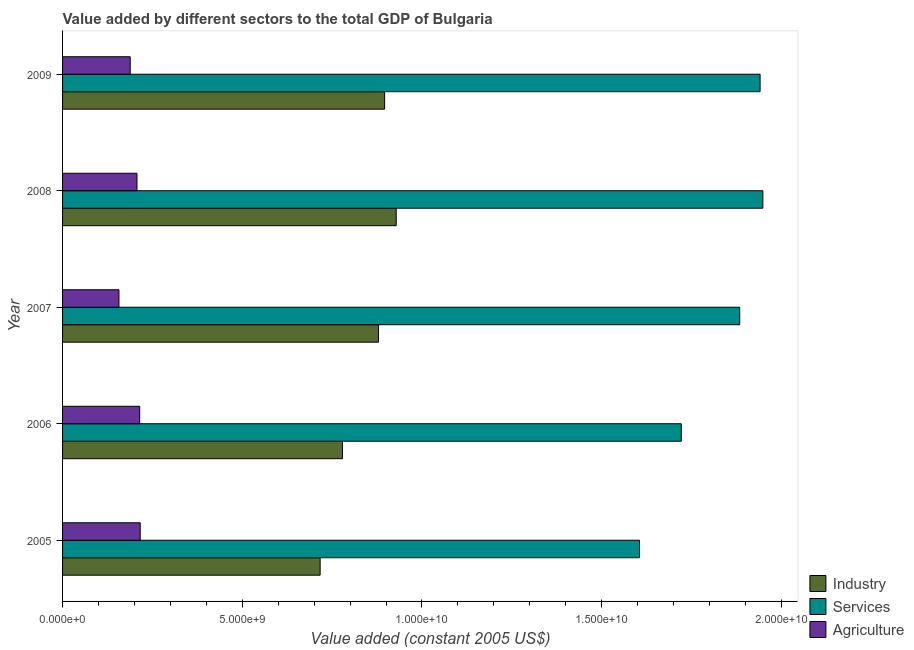How many different coloured bars are there?
Provide a short and direct response. 3. How many groups of bars are there?
Your response must be concise. 5. Are the number of bars on each tick of the Y-axis equal?
Provide a short and direct response. Yes. How many bars are there on the 1st tick from the top?
Ensure brevity in your answer.  3. How many bars are there on the 4th tick from the bottom?
Your answer should be very brief. 3. What is the label of the 4th group of bars from the top?
Ensure brevity in your answer.  2006. What is the value added by services in 2005?
Give a very brief answer. 1.61e+1. Across all years, what is the maximum value added by agricultural sector?
Your answer should be compact. 2.16e+09. Across all years, what is the minimum value added by industrial sector?
Keep it short and to the point. 7.17e+09. What is the total value added by industrial sector in the graph?
Your answer should be very brief. 4.20e+1. What is the difference between the value added by agricultural sector in 2007 and that in 2008?
Offer a terse response. -5.01e+08. What is the difference between the value added by agricultural sector in 2007 and the value added by services in 2009?
Offer a very short reply. -1.78e+1. What is the average value added by agricultural sector per year?
Your answer should be very brief. 1.97e+09. In the year 2009, what is the difference between the value added by services and value added by industrial sector?
Keep it short and to the point. 1.04e+1. What is the ratio of the value added by agricultural sector in 2005 to that in 2009?
Offer a very short reply. 1.15. What is the difference between the highest and the second highest value added by services?
Provide a short and direct response. 7.76e+07. What is the difference between the highest and the lowest value added by agricultural sector?
Your answer should be compact. 5.91e+08. What does the 2nd bar from the top in 2005 represents?
Your answer should be compact. Services. What does the 2nd bar from the bottom in 2008 represents?
Your answer should be compact. Services. Are all the bars in the graph horizontal?
Ensure brevity in your answer.  Yes. What is the difference between two consecutive major ticks on the X-axis?
Give a very brief answer. 5.00e+09. Are the values on the major ticks of X-axis written in scientific E-notation?
Make the answer very short. Yes. Does the graph contain any zero values?
Your answer should be very brief. No. Where does the legend appear in the graph?
Offer a terse response. Bottom right. How many legend labels are there?
Your answer should be compact. 3. What is the title of the graph?
Offer a very short reply. Value added by different sectors to the total GDP of Bulgaria. What is the label or title of the X-axis?
Make the answer very short. Value added (constant 2005 US$). What is the Value added (constant 2005 US$) in Industry in 2005?
Your response must be concise. 7.17e+09. What is the Value added (constant 2005 US$) in Services in 2005?
Make the answer very short. 1.61e+1. What is the Value added (constant 2005 US$) in Agriculture in 2005?
Keep it short and to the point. 2.16e+09. What is the Value added (constant 2005 US$) of Industry in 2006?
Provide a short and direct response. 7.79e+09. What is the Value added (constant 2005 US$) of Services in 2006?
Your response must be concise. 1.72e+1. What is the Value added (constant 2005 US$) of Agriculture in 2006?
Offer a very short reply. 2.15e+09. What is the Value added (constant 2005 US$) in Industry in 2007?
Your response must be concise. 8.79e+09. What is the Value added (constant 2005 US$) of Services in 2007?
Your response must be concise. 1.88e+1. What is the Value added (constant 2005 US$) of Agriculture in 2007?
Ensure brevity in your answer.  1.57e+09. What is the Value added (constant 2005 US$) of Industry in 2008?
Your answer should be compact. 9.28e+09. What is the Value added (constant 2005 US$) of Services in 2008?
Provide a succinct answer. 1.95e+1. What is the Value added (constant 2005 US$) of Agriculture in 2008?
Ensure brevity in your answer.  2.07e+09. What is the Value added (constant 2005 US$) in Industry in 2009?
Your answer should be very brief. 8.96e+09. What is the Value added (constant 2005 US$) of Services in 2009?
Provide a short and direct response. 1.94e+1. What is the Value added (constant 2005 US$) in Agriculture in 2009?
Your answer should be compact. 1.88e+09. Across all years, what is the maximum Value added (constant 2005 US$) of Industry?
Ensure brevity in your answer.  9.28e+09. Across all years, what is the maximum Value added (constant 2005 US$) of Services?
Provide a short and direct response. 1.95e+1. Across all years, what is the maximum Value added (constant 2005 US$) in Agriculture?
Provide a short and direct response. 2.16e+09. Across all years, what is the minimum Value added (constant 2005 US$) in Industry?
Offer a very short reply. 7.17e+09. Across all years, what is the minimum Value added (constant 2005 US$) in Services?
Offer a very short reply. 1.61e+1. Across all years, what is the minimum Value added (constant 2005 US$) of Agriculture?
Offer a terse response. 1.57e+09. What is the total Value added (constant 2005 US$) of Industry in the graph?
Keep it short and to the point. 4.20e+1. What is the total Value added (constant 2005 US$) of Services in the graph?
Your answer should be compact. 9.10e+1. What is the total Value added (constant 2005 US$) in Agriculture in the graph?
Offer a very short reply. 9.83e+09. What is the difference between the Value added (constant 2005 US$) of Industry in 2005 and that in 2006?
Provide a succinct answer. -6.23e+08. What is the difference between the Value added (constant 2005 US$) of Services in 2005 and that in 2006?
Ensure brevity in your answer.  -1.16e+09. What is the difference between the Value added (constant 2005 US$) in Agriculture in 2005 and that in 2006?
Make the answer very short. 1.41e+07. What is the difference between the Value added (constant 2005 US$) of Industry in 2005 and that in 2007?
Keep it short and to the point. -1.62e+09. What is the difference between the Value added (constant 2005 US$) of Services in 2005 and that in 2007?
Make the answer very short. -2.79e+09. What is the difference between the Value added (constant 2005 US$) in Agriculture in 2005 and that in 2007?
Ensure brevity in your answer.  5.91e+08. What is the difference between the Value added (constant 2005 US$) of Industry in 2005 and that in 2008?
Ensure brevity in your answer.  -2.12e+09. What is the difference between the Value added (constant 2005 US$) in Services in 2005 and that in 2008?
Your answer should be very brief. -3.43e+09. What is the difference between the Value added (constant 2005 US$) in Agriculture in 2005 and that in 2008?
Your answer should be compact. 9.00e+07. What is the difference between the Value added (constant 2005 US$) in Industry in 2005 and that in 2009?
Make the answer very short. -1.79e+09. What is the difference between the Value added (constant 2005 US$) of Services in 2005 and that in 2009?
Ensure brevity in your answer.  -3.35e+09. What is the difference between the Value added (constant 2005 US$) in Agriculture in 2005 and that in 2009?
Make the answer very short. 2.78e+08. What is the difference between the Value added (constant 2005 US$) in Industry in 2006 and that in 2007?
Make the answer very short. -1.00e+09. What is the difference between the Value added (constant 2005 US$) of Services in 2006 and that in 2007?
Your response must be concise. -1.63e+09. What is the difference between the Value added (constant 2005 US$) of Agriculture in 2006 and that in 2007?
Ensure brevity in your answer.  5.77e+08. What is the difference between the Value added (constant 2005 US$) of Industry in 2006 and that in 2008?
Keep it short and to the point. -1.49e+09. What is the difference between the Value added (constant 2005 US$) of Services in 2006 and that in 2008?
Provide a short and direct response. -2.27e+09. What is the difference between the Value added (constant 2005 US$) of Agriculture in 2006 and that in 2008?
Your answer should be very brief. 7.59e+07. What is the difference between the Value added (constant 2005 US$) in Industry in 2006 and that in 2009?
Give a very brief answer. -1.17e+09. What is the difference between the Value added (constant 2005 US$) of Services in 2006 and that in 2009?
Your answer should be very brief. -2.19e+09. What is the difference between the Value added (constant 2005 US$) in Agriculture in 2006 and that in 2009?
Give a very brief answer. 2.64e+08. What is the difference between the Value added (constant 2005 US$) in Industry in 2007 and that in 2008?
Offer a terse response. -4.94e+08. What is the difference between the Value added (constant 2005 US$) in Services in 2007 and that in 2008?
Provide a short and direct response. -6.44e+08. What is the difference between the Value added (constant 2005 US$) in Agriculture in 2007 and that in 2008?
Offer a very short reply. -5.01e+08. What is the difference between the Value added (constant 2005 US$) of Industry in 2007 and that in 2009?
Offer a terse response. -1.71e+08. What is the difference between the Value added (constant 2005 US$) of Services in 2007 and that in 2009?
Offer a terse response. -5.67e+08. What is the difference between the Value added (constant 2005 US$) in Agriculture in 2007 and that in 2009?
Your answer should be very brief. -3.13e+08. What is the difference between the Value added (constant 2005 US$) of Industry in 2008 and that in 2009?
Ensure brevity in your answer.  3.23e+08. What is the difference between the Value added (constant 2005 US$) of Services in 2008 and that in 2009?
Keep it short and to the point. 7.76e+07. What is the difference between the Value added (constant 2005 US$) of Agriculture in 2008 and that in 2009?
Give a very brief answer. 1.88e+08. What is the difference between the Value added (constant 2005 US$) of Industry in 2005 and the Value added (constant 2005 US$) of Services in 2006?
Give a very brief answer. -1.00e+1. What is the difference between the Value added (constant 2005 US$) in Industry in 2005 and the Value added (constant 2005 US$) in Agriculture in 2006?
Keep it short and to the point. 5.02e+09. What is the difference between the Value added (constant 2005 US$) of Services in 2005 and the Value added (constant 2005 US$) of Agriculture in 2006?
Offer a very short reply. 1.39e+1. What is the difference between the Value added (constant 2005 US$) in Industry in 2005 and the Value added (constant 2005 US$) in Services in 2007?
Provide a short and direct response. -1.17e+1. What is the difference between the Value added (constant 2005 US$) in Industry in 2005 and the Value added (constant 2005 US$) in Agriculture in 2007?
Ensure brevity in your answer.  5.60e+09. What is the difference between the Value added (constant 2005 US$) in Services in 2005 and the Value added (constant 2005 US$) in Agriculture in 2007?
Ensure brevity in your answer.  1.45e+1. What is the difference between the Value added (constant 2005 US$) in Industry in 2005 and the Value added (constant 2005 US$) in Services in 2008?
Your response must be concise. -1.23e+1. What is the difference between the Value added (constant 2005 US$) in Industry in 2005 and the Value added (constant 2005 US$) in Agriculture in 2008?
Provide a short and direct response. 5.10e+09. What is the difference between the Value added (constant 2005 US$) in Services in 2005 and the Value added (constant 2005 US$) in Agriculture in 2008?
Offer a very short reply. 1.40e+1. What is the difference between the Value added (constant 2005 US$) in Industry in 2005 and the Value added (constant 2005 US$) in Services in 2009?
Offer a very short reply. -1.22e+1. What is the difference between the Value added (constant 2005 US$) of Industry in 2005 and the Value added (constant 2005 US$) of Agriculture in 2009?
Give a very brief answer. 5.28e+09. What is the difference between the Value added (constant 2005 US$) in Services in 2005 and the Value added (constant 2005 US$) in Agriculture in 2009?
Offer a terse response. 1.42e+1. What is the difference between the Value added (constant 2005 US$) of Industry in 2006 and the Value added (constant 2005 US$) of Services in 2007?
Your answer should be very brief. -1.11e+1. What is the difference between the Value added (constant 2005 US$) in Industry in 2006 and the Value added (constant 2005 US$) in Agriculture in 2007?
Keep it short and to the point. 6.22e+09. What is the difference between the Value added (constant 2005 US$) of Services in 2006 and the Value added (constant 2005 US$) of Agriculture in 2007?
Your answer should be very brief. 1.56e+1. What is the difference between the Value added (constant 2005 US$) in Industry in 2006 and the Value added (constant 2005 US$) in Services in 2008?
Make the answer very short. -1.17e+1. What is the difference between the Value added (constant 2005 US$) in Industry in 2006 and the Value added (constant 2005 US$) in Agriculture in 2008?
Offer a terse response. 5.72e+09. What is the difference between the Value added (constant 2005 US$) in Services in 2006 and the Value added (constant 2005 US$) in Agriculture in 2008?
Offer a very short reply. 1.51e+1. What is the difference between the Value added (constant 2005 US$) in Industry in 2006 and the Value added (constant 2005 US$) in Services in 2009?
Keep it short and to the point. -1.16e+1. What is the difference between the Value added (constant 2005 US$) of Industry in 2006 and the Value added (constant 2005 US$) of Agriculture in 2009?
Keep it short and to the point. 5.91e+09. What is the difference between the Value added (constant 2005 US$) in Services in 2006 and the Value added (constant 2005 US$) in Agriculture in 2009?
Your answer should be compact. 1.53e+1. What is the difference between the Value added (constant 2005 US$) in Industry in 2007 and the Value added (constant 2005 US$) in Services in 2008?
Your answer should be compact. -1.07e+1. What is the difference between the Value added (constant 2005 US$) in Industry in 2007 and the Value added (constant 2005 US$) in Agriculture in 2008?
Provide a short and direct response. 6.72e+09. What is the difference between the Value added (constant 2005 US$) in Services in 2007 and the Value added (constant 2005 US$) in Agriculture in 2008?
Provide a short and direct response. 1.68e+1. What is the difference between the Value added (constant 2005 US$) in Industry in 2007 and the Value added (constant 2005 US$) in Services in 2009?
Offer a terse response. -1.06e+1. What is the difference between the Value added (constant 2005 US$) in Industry in 2007 and the Value added (constant 2005 US$) in Agriculture in 2009?
Give a very brief answer. 6.91e+09. What is the difference between the Value added (constant 2005 US$) in Services in 2007 and the Value added (constant 2005 US$) in Agriculture in 2009?
Provide a short and direct response. 1.70e+1. What is the difference between the Value added (constant 2005 US$) of Industry in 2008 and the Value added (constant 2005 US$) of Services in 2009?
Make the answer very short. -1.01e+1. What is the difference between the Value added (constant 2005 US$) of Industry in 2008 and the Value added (constant 2005 US$) of Agriculture in 2009?
Your answer should be compact. 7.40e+09. What is the difference between the Value added (constant 2005 US$) of Services in 2008 and the Value added (constant 2005 US$) of Agriculture in 2009?
Provide a succinct answer. 1.76e+1. What is the average Value added (constant 2005 US$) in Industry per year?
Provide a short and direct response. 8.40e+09. What is the average Value added (constant 2005 US$) in Services per year?
Offer a very short reply. 1.82e+1. What is the average Value added (constant 2005 US$) of Agriculture per year?
Offer a terse response. 1.97e+09. In the year 2005, what is the difference between the Value added (constant 2005 US$) in Industry and Value added (constant 2005 US$) in Services?
Provide a succinct answer. -8.89e+09. In the year 2005, what is the difference between the Value added (constant 2005 US$) in Industry and Value added (constant 2005 US$) in Agriculture?
Provide a succinct answer. 5.01e+09. In the year 2005, what is the difference between the Value added (constant 2005 US$) in Services and Value added (constant 2005 US$) in Agriculture?
Your answer should be compact. 1.39e+1. In the year 2006, what is the difference between the Value added (constant 2005 US$) of Industry and Value added (constant 2005 US$) of Services?
Your response must be concise. -9.43e+09. In the year 2006, what is the difference between the Value added (constant 2005 US$) of Industry and Value added (constant 2005 US$) of Agriculture?
Provide a succinct answer. 5.64e+09. In the year 2006, what is the difference between the Value added (constant 2005 US$) of Services and Value added (constant 2005 US$) of Agriculture?
Ensure brevity in your answer.  1.51e+1. In the year 2007, what is the difference between the Value added (constant 2005 US$) of Industry and Value added (constant 2005 US$) of Services?
Give a very brief answer. -1.01e+1. In the year 2007, what is the difference between the Value added (constant 2005 US$) in Industry and Value added (constant 2005 US$) in Agriculture?
Ensure brevity in your answer.  7.22e+09. In the year 2007, what is the difference between the Value added (constant 2005 US$) in Services and Value added (constant 2005 US$) in Agriculture?
Give a very brief answer. 1.73e+1. In the year 2008, what is the difference between the Value added (constant 2005 US$) of Industry and Value added (constant 2005 US$) of Services?
Your answer should be very brief. -1.02e+1. In the year 2008, what is the difference between the Value added (constant 2005 US$) in Industry and Value added (constant 2005 US$) in Agriculture?
Offer a very short reply. 7.21e+09. In the year 2008, what is the difference between the Value added (constant 2005 US$) in Services and Value added (constant 2005 US$) in Agriculture?
Offer a very short reply. 1.74e+1. In the year 2009, what is the difference between the Value added (constant 2005 US$) in Industry and Value added (constant 2005 US$) in Services?
Provide a short and direct response. -1.04e+1. In the year 2009, what is the difference between the Value added (constant 2005 US$) of Industry and Value added (constant 2005 US$) of Agriculture?
Offer a very short reply. 7.08e+09. In the year 2009, what is the difference between the Value added (constant 2005 US$) in Services and Value added (constant 2005 US$) in Agriculture?
Give a very brief answer. 1.75e+1. What is the ratio of the Value added (constant 2005 US$) in Services in 2005 to that in 2006?
Your answer should be very brief. 0.93. What is the ratio of the Value added (constant 2005 US$) of Agriculture in 2005 to that in 2006?
Provide a succinct answer. 1.01. What is the ratio of the Value added (constant 2005 US$) in Industry in 2005 to that in 2007?
Offer a very short reply. 0.82. What is the ratio of the Value added (constant 2005 US$) in Services in 2005 to that in 2007?
Ensure brevity in your answer.  0.85. What is the ratio of the Value added (constant 2005 US$) in Agriculture in 2005 to that in 2007?
Keep it short and to the point. 1.38. What is the ratio of the Value added (constant 2005 US$) of Industry in 2005 to that in 2008?
Give a very brief answer. 0.77. What is the ratio of the Value added (constant 2005 US$) of Services in 2005 to that in 2008?
Your answer should be very brief. 0.82. What is the ratio of the Value added (constant 2005 US$) in Agriculture in 2005 to that in 2008?
Offer a very short reply. 1.04. What is the ratio of the Value added (constant 2005 US$) in Industry in 2005 to that in 2009?
Make the answer very short. 0.8. What is the ratio of the Value added (constant 2005 US$) in Services in 2005 to that in 2009?
Your answer should be very brief. 0.83. What is the ratio of the Value added (constant 2005 US$) in Agriculture in 2005 to that in 2009?
Keep it short and to the point. 1.15. What is the ratio of the Value added (constant 2005 US$) of Industry in 2006 to that in 2007?
Keep it short and to the point. 0.89. What is the ratio of the Value added (constant 2005 US$) of Services in 2006 to that in 2007?
Your answer should be very brief. 0.91. What is the ratio of the Value added (constant 2005 US$) of Agriculture in 2006 to that in 2007?
Provide a succinct answer. 1.37. What is the ratio of the Value added (constant 2005 US$) of Industry in 2006 to that in 2008?
Ensure brevity in your answer.  0.84. What is the ratio of the Value added (constant 2005 US$) in Services in 2006 to that in 2008?
Your answer should be compact. 0.88. What is the ratio of the Value added (constant 2005 US$) in Agriculture in 2006 to that in 2008?
Offer a terse response. 1.04. What is the ratio of the Value added (constant 2005 US$) in Industry in 2006 to that in 2009?
Your response must be concise. 0.87. What is the ratio of the Value added (constant 2005 US$) of Services in 2006 to that in 2009?
Make the answer very short. 0.89. What is the ratio of the Value added (constant 2005 US$) of Agriculture in 2006 to that in 2009?
Offer a terse response. 1.14. What is the ratio of the Value added (constant 2005 US$) of Industry in 2007 to that in 2008?
Your answer should be very brief. 0.95. What is the ratio of the Value added (constant 2005 US$) of Services in 2007 to that in 2008?
Make the answer very short. 0.97. What is the ratio of the Value added (constant 2005 US$) in Agriculture in 2007 to that in 2008?
Ensure brevity in your answer.  0.76. What is the ratio of the Value added (constant 2005 US$) of Industry in 2007 to that in 2009?
Keep it short and to the point. 0.98. What is the ratio of the Value added (constant 2005 US$) of Services in 2007 to that in 2009?
Keep it short and to the point. 0.97. What is the ratio of the Value added (constant 2005 US$) in Agriculture in 2007 to that in 2009?
Your answer should be very brief. 0.83. What is the ratio of the Value added (constant 2005 US$) of Industry in 2008 to that in 2009?
Give a very brief answer. 1.04. What is the ratio of the Value added (constant 2005 US$) in Services in 2008 to that in 2009?
Ensure brevity in your answer.  1. What is the ratio of the Value added (constant 2005 US$) in Agriculture in 2008 to that in 2009?
Your answer should be compact. 1.1. What is the difference between the highest and the second highest Value added (constant 2005 US$) of Industry?
Offer a terse response. 3.23e+08. What is the difference between the highest and the second highest Value added (constant 2005 US$) of Services?
Offer a very short reply. 7.76e+07. What is the difference between the highest and the second highest Value added (constant 2005 US$) of Agriculture?
Ensure brevity in your answer.  1.41e+07. What is the difference between the highest and the lowest Value added (constant 2005 US$) of Industry?
Offer a very short reply. 2.12e+09. What is the difference between the highest and the lowest Value added (constant 2005 US$) in Services?
Provide a short and direct response. 3.43e+09. What is the difference between the highest and the lowest Value added (constant 2005 US$) of Agriculture?
Give a very brief answer. 5.91e+08. 